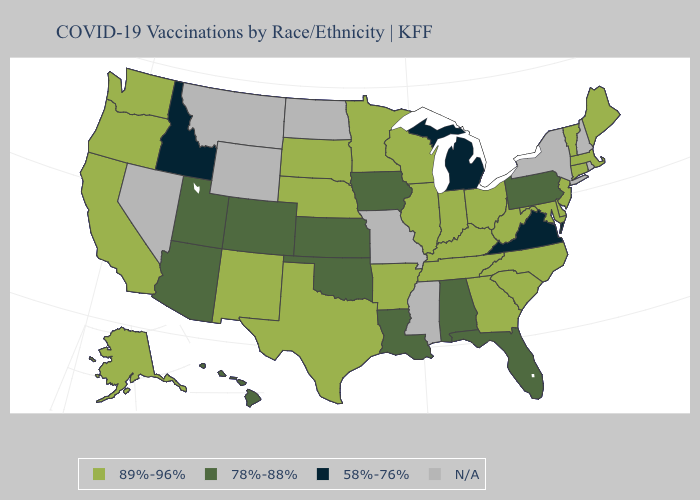What is the highest value in the USA?
Give a very brief answer. 89%-96%. What is the value of Kansas?
Quick response, please. 78%-88%. Does Virginia have the lowest value in the USA?
Be succinct. Yes. What is the highest value in the USA?
Give a very brief answer. 89%-96%. How many symbols are there in the legend?
Concise answer only. 4. What is the value of Florida?
Keep it brief. 78%-88%. Name the states that have a value in the range 78%-88%?
Write a very short answer. Alabama, Arizona, Colorado, Florida, Hawaii, Iowa, Kansas, Louisiana, Oklahoma, Pennsylvania, Utah. What is the value of New Hampshire?
Concise answer only. N/A. What is the lowest value in states that border South Carolina?
Answer briefly. 89%-96%. What is the value of Wyoming?
Concise answer only. N/A. Name the states that have a value in the range 89%-96%?
Answer briefly. Alaska, Arkansas, California, Connecticut, Delaware, Georgia, Illinois, Indiana, Kentucky, Maine, Maryland, Massachusetts, Minnesota, Nebraska, New Jersey, New Mexico, North Carolina, Ohio, Oregon, South Carolina, South Dakota, Tennessee, Texas, Vermont, Washington, West Virginia, Wisconsin. 